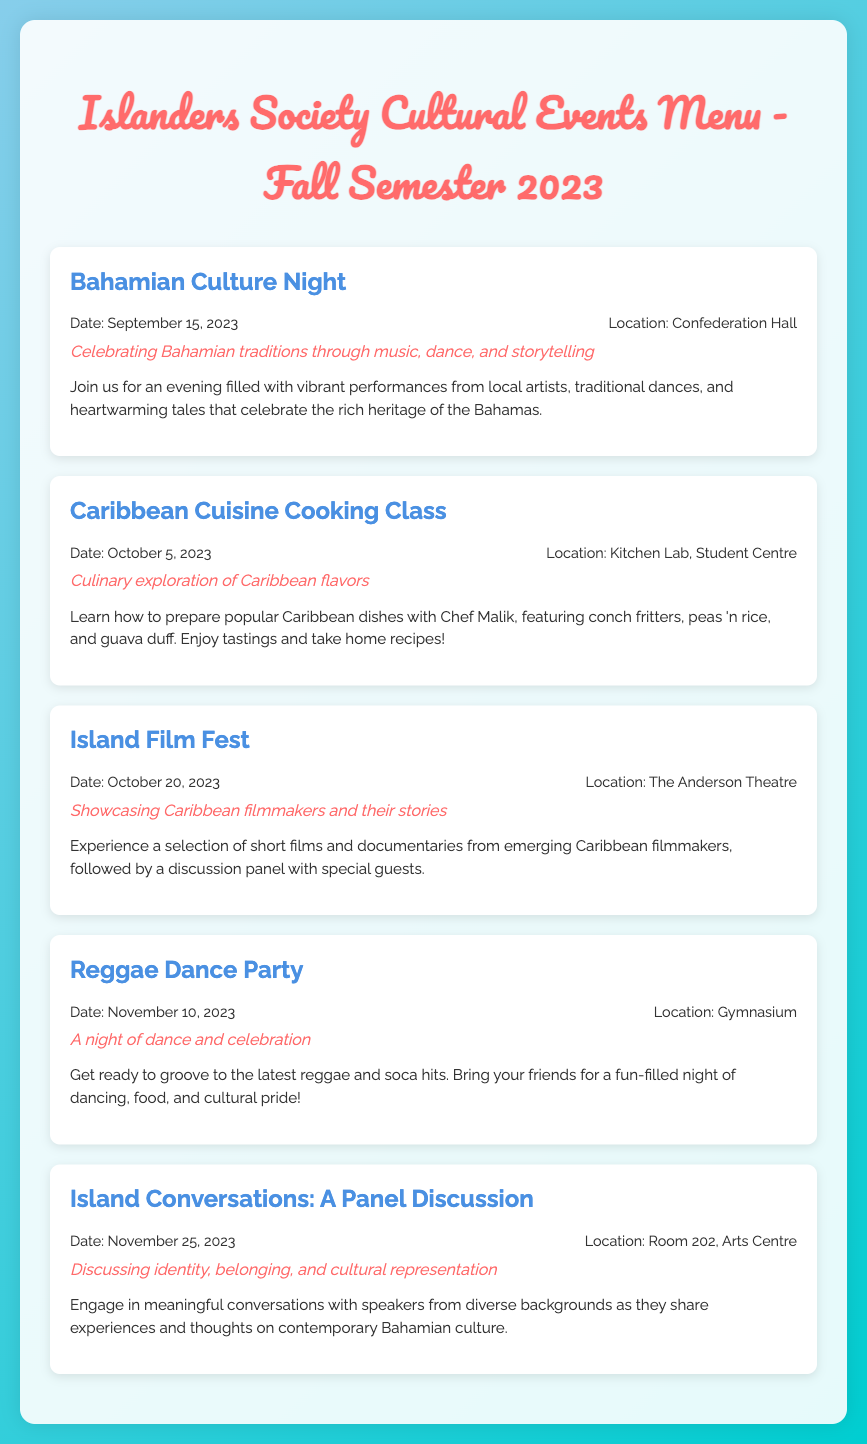What is the date of Bahamian Culture Night? The date for Bahamian Culture Night is provided in the event details section within the document.
Answer: September 15, 2023 Where will the Caribbean Cuisine Cooking Class take place? The location of the Caribbean Cuisine Cooking Class is specified in the event details section.
Answer: Kitchen Lab, Student Centre What theme is associated with the Island Film Fest? The theme for the Island Film Fest is mentioned below the event title in the event description.
Answer: Showcasing Caribbean filmmakers and their stories What is the date of the Reggae Dance Party? The date of the Reggae Dance Party is mentioned in the event details section.
Answer: November 10, 2023 Which event focuses on identity and cultural representation? The document lists specific events and their themes, and this particular focus is defined under one of the event titles.
Answer: Island Conversations: A Panel Discussion How many cultural events are listed in the menu? To find the total events, count the number of event sections presented in the document.
Answer: Five What type of performances can attendees expect at Bahamian Culture Night? The event description for Bahamian Culture Night provides details on the types of performances.
Answer: Music, dance, and storytelling Which event takes place in the Gymnasium? The document specifies locations for each cultural event, allowing direct retrieval of the venue for the Reggae Dance Party.
Answer: Reggae Dance Party 